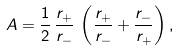<formula> <loc_0><loc_0><loc_500><loc_500>A = \frac { 1 } { 2 } \, \frac { r _ { + } } { r _ { - } } \, \left ( \frac { r _ { + } } { r _ { - } } + \frac { r _ { - } } { r _ { + } } \right ) ,</formula> 